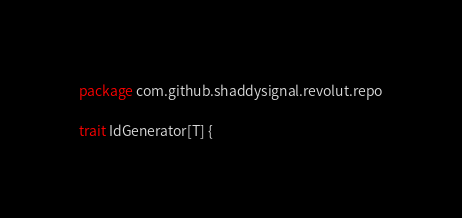Convert code to text. <code><loc_0><loc_0><loc_500><loc_500><_Scala_>package com.github.shaddysignal.revolut.repo

trait IdGenerator[T] {</code> 